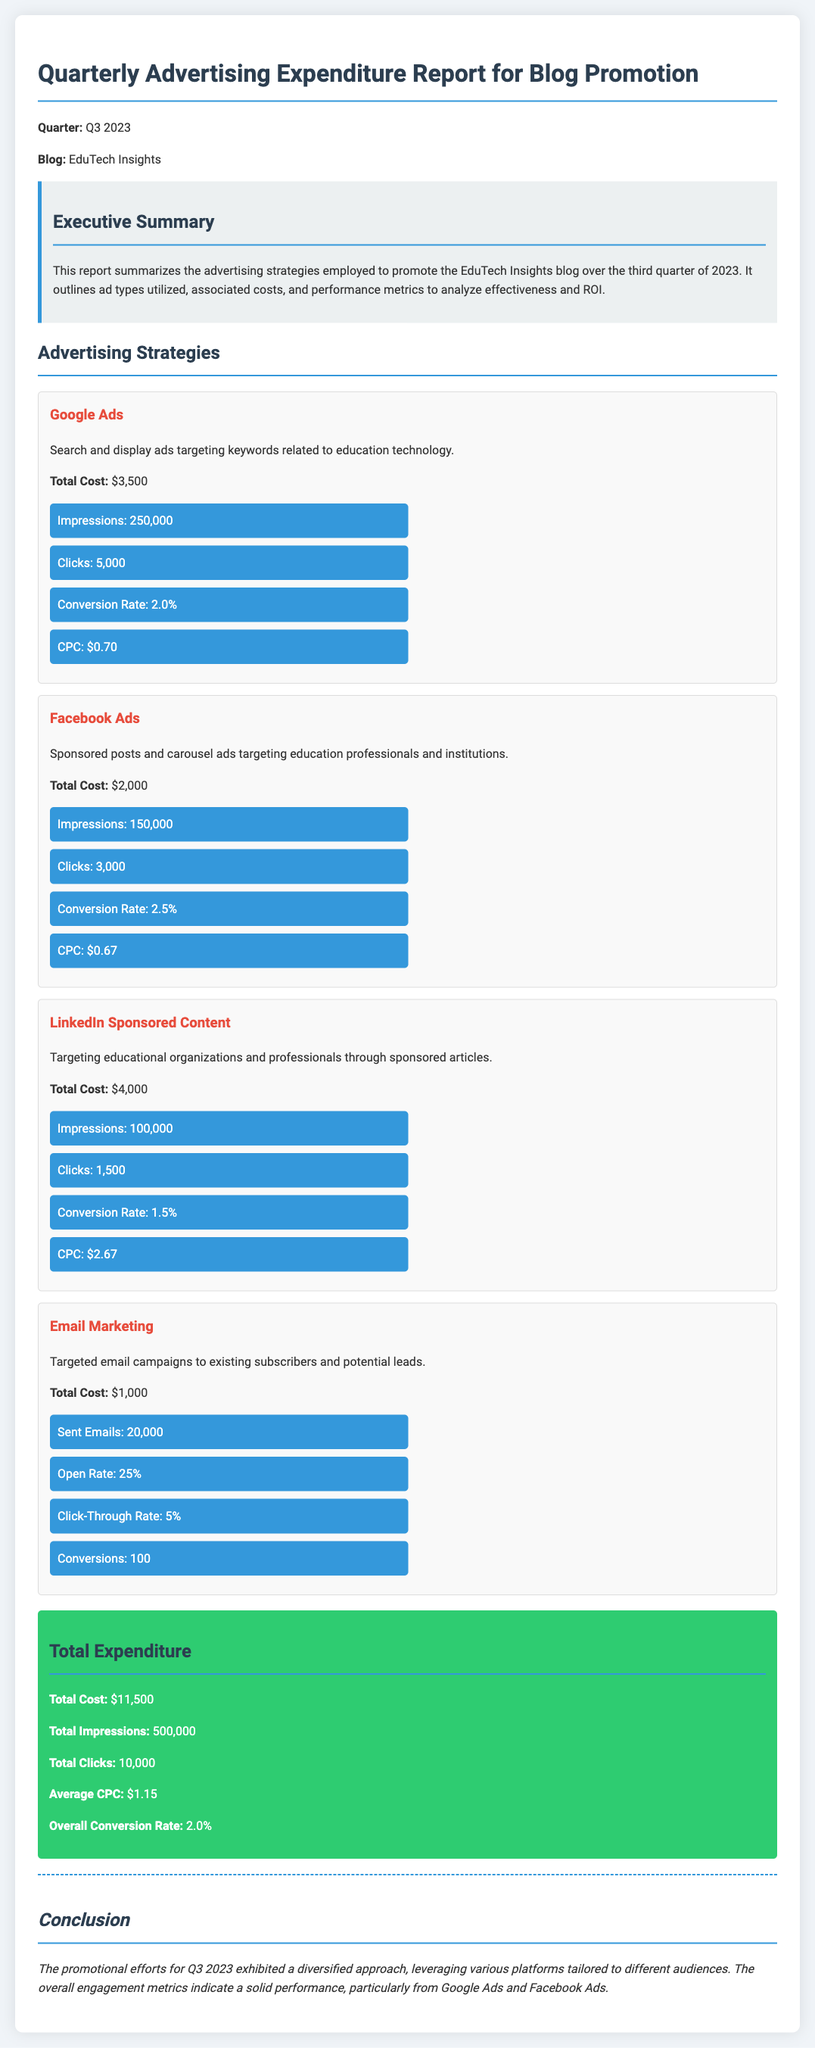What is the total expenditure for Q3 2023? The total expenditure is mentioned in the total expenditure section of the document, which states the total cost.
Answer: $11,500 How much was spent on Google Ads? The amount spent on Google Ads is listed under the corresponding ad strategy, which shows the total cost for Google Ads.
Answer: $3,500 What is the conversion rate for Facebook Ads? The conversion rate for Facebook Ads can be found in the metrics section of the Facebook Ads strategy.
Answer: 2.5% What is the number of clicks generated by LinkedIn Sponsored Content? The number of clicks for LinkedIn Sponsored Content can be retrieved from the metrics section of that ad strategy.
Answer: 1,500 What was the open rate for Email Marketing? The open rate for Email Marketing is specified in the metrics section of that advertising strategy.
Answer: 25% Which ad type had the highest cost? By reviewing the total costs of each ad type, one can determine which had the highest expenditure.
Answer: LinkedIn Sponsored Content How many impressions were achieved through all advertising strategies combined? The total impressions can be found at the bottom of the total expenditure section, summing the impressions from all ad types.
Answer: 500,000 What was the overall conversion rate reported in the document? The overall conversion rate is provided in the total expenditure section at the end of the report.
Answer: 2.0% What platform generated the most impressions? The impressions for each ad type are listed, and one can identify the platform that generated the most impressions.
Answer: Google Ads 